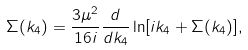Convert formula to latex. <formula><loc_0><loc_0><loc_500><loc_500>\Sigma ( k _ { 4 } ) = \frac { 3 \mu ^ { 2 } } { 1 6 i } \frac { d } { d k _ { 4 } } \ln [ i k _ { 4 } + \Sigma ( k _ { 4 } ) ] ,</formula> 